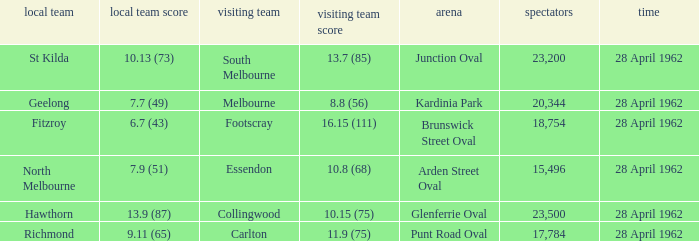What was the crowd size when there was a home team score of 10.13 (73)? 23200.0. 